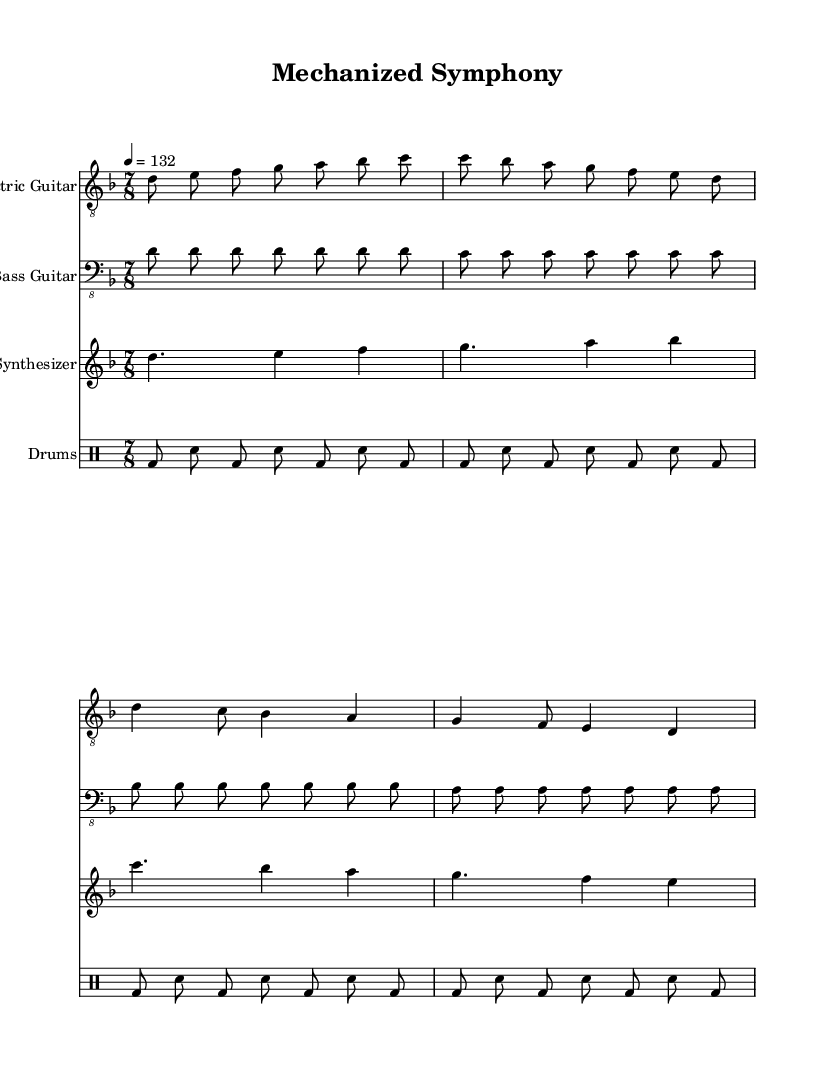What is the key signature of this music? The key signature shows two flats, indicating that the piece is in D minor. The clef signs help identify which notes correspond to which pitches, confirming the key.
Answer: D minor What is the time signature of this music? The time signature is located at the beginning of the score, represented as 7/8, which indicates there are seven eighth notes per measure.
Answer: 7/8 What is the tempo marking in this music? The tempo marking is indicated by the number '132' with the quarter note unit. This shows the speed of the piece, suggesting it should be played at 132 beats per minute.
Answer: 132 How many measures does the electric guitar part contain? By counting the segments divided by the bar lines, the electric guitar part has a total of four measures. Each distinct grouping results in a different measure count.
Answer: 4 Which instrument has the highest pitch range in this score? To determine the highest pitch range, we look at the clef and notated pitches. The electric guitar and synthesizer both contain higher notes, but the synthesizer overall reaches higher pitches than the electric guitar.
Answer: Synthesizer How does the rhythmic pattern of the drums contribute to the industrial soundscape? The rhythmic pattern of the drums is consistent, embodying mechanical, industrial elements through repetitive beats (bass drum and snare). This imitates the steady pulse of industrial processes, creating an immersive environment typical of experimental metal-fusion.
Answer: Mechanical What style of music does this score represent? The sheet music showcases elements of experimental metal-fusion, characterized by heavy instrumentation, complex rhythms, and diverse sounds meant to mimic industrial environments.
Answer: Experimental metal-fusion 